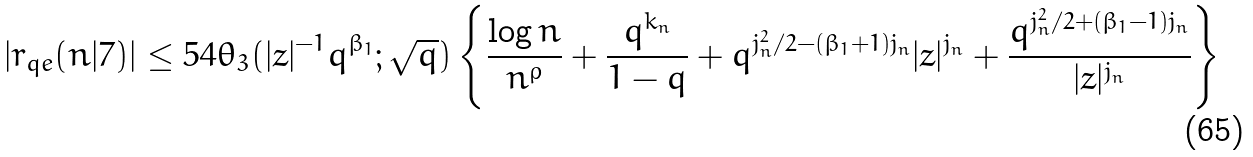Convert formula to latex. <formula><loc_0><loc_0><loc_500><loc_500>| r _ { q e } ( n | 7 ) | \leq 5 4 \theta _ { 3 } ( | z | ^ { - 1 } q ^ { \beta _ { 1 } } ; \sqrt { q } ) \left \{ \frac { \log n } { n ^ { \rho } } + \frac { q ^ { k _ { n } } } { 1 - q } + q ^ { j _ { n } ^ { 2 } / 2 - ( \beta _ { 1 } + 1 ) j _ { n } } | z | ^ { j _ { n } } + \frac { q ^ { j _ { n } ^ { 2 } / 2 + ( \beta _ { 1 } - 1 ) j _ { n } } } { | z | ^ { j _ { n } } } \right \}</formula> 